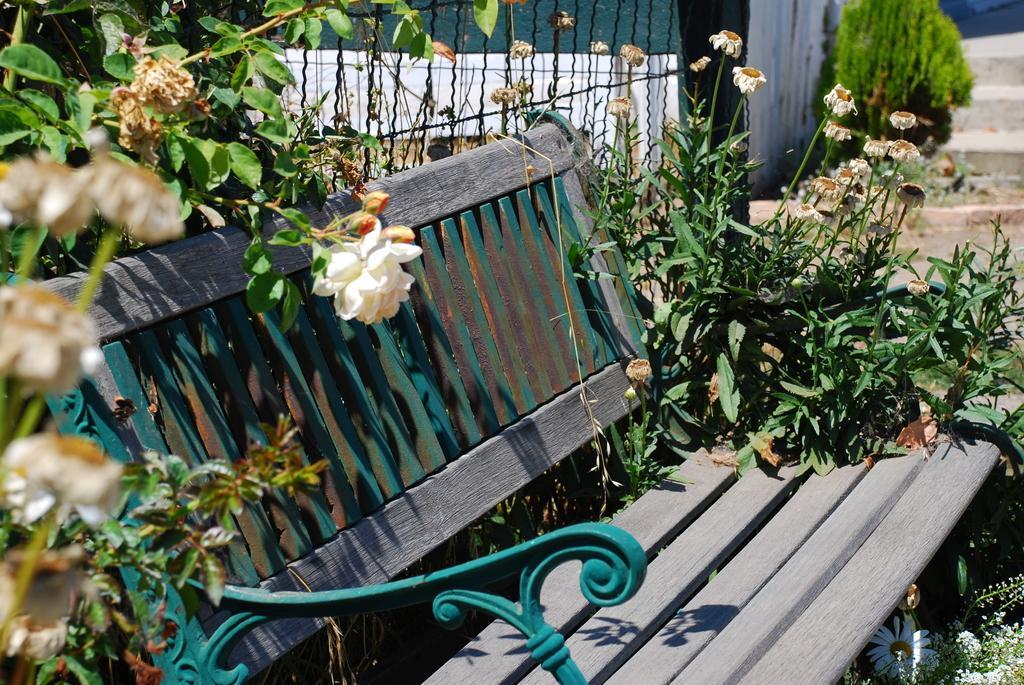Could you give a brief overview of what you see in this image? In the image in the center we can see bench. Around bench we can see plants,flowers. In the background there is a staircase. 